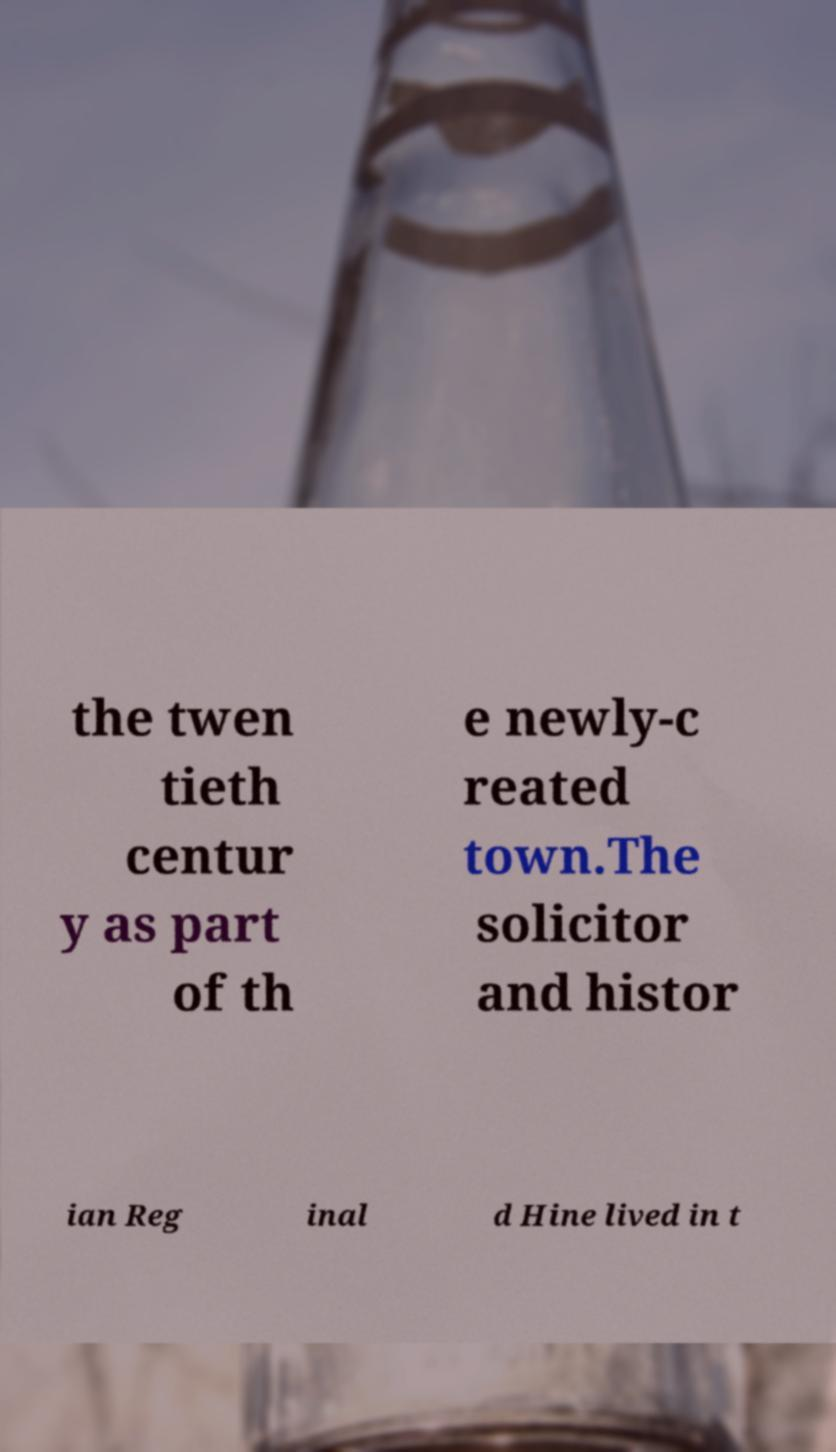Please identify and transcribe the text found in this image. the twen tieth centur y as part of th e newly-c reated town.The solicitor and histor ian Reg inal d Hine lived in t 